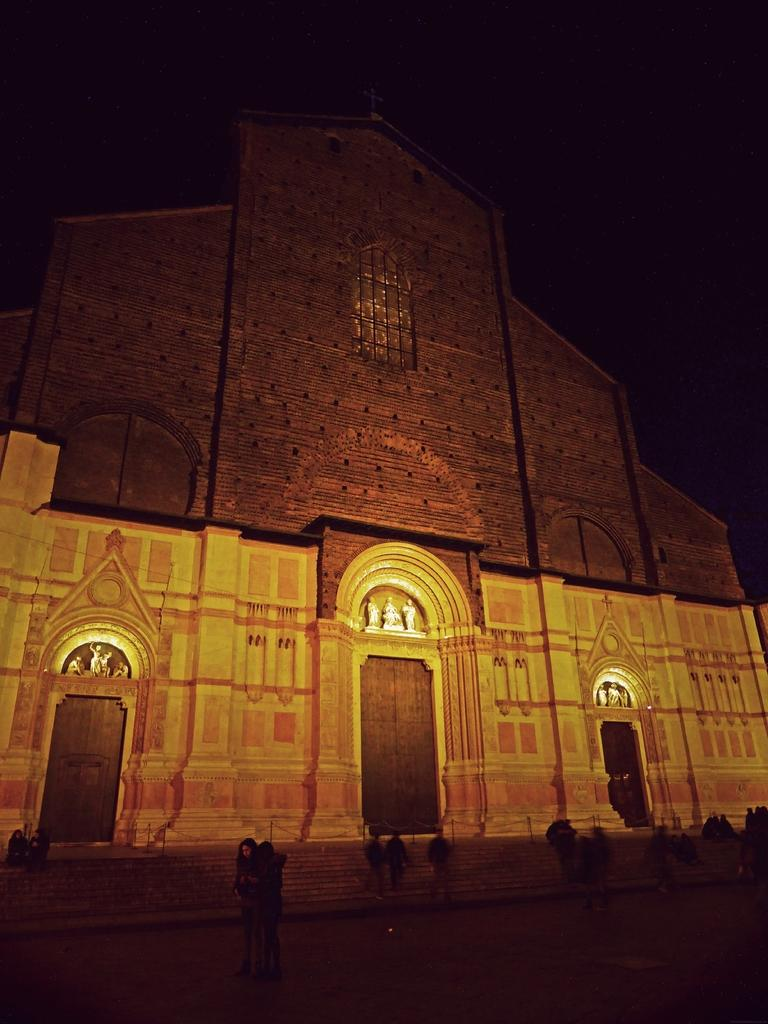What time of day was the image taken? The image was taken during night time. What can be seen in the background of the image? There is a monument in the background of the image. Are there any people visible in the image? Yes, there are people visible in the image. What architectural feature is present in the image? Stairs are present in the image. What type of produce is being sold by the people in the image? There is no produce visible in the image; it features a monument, stairs, and people during night time. 